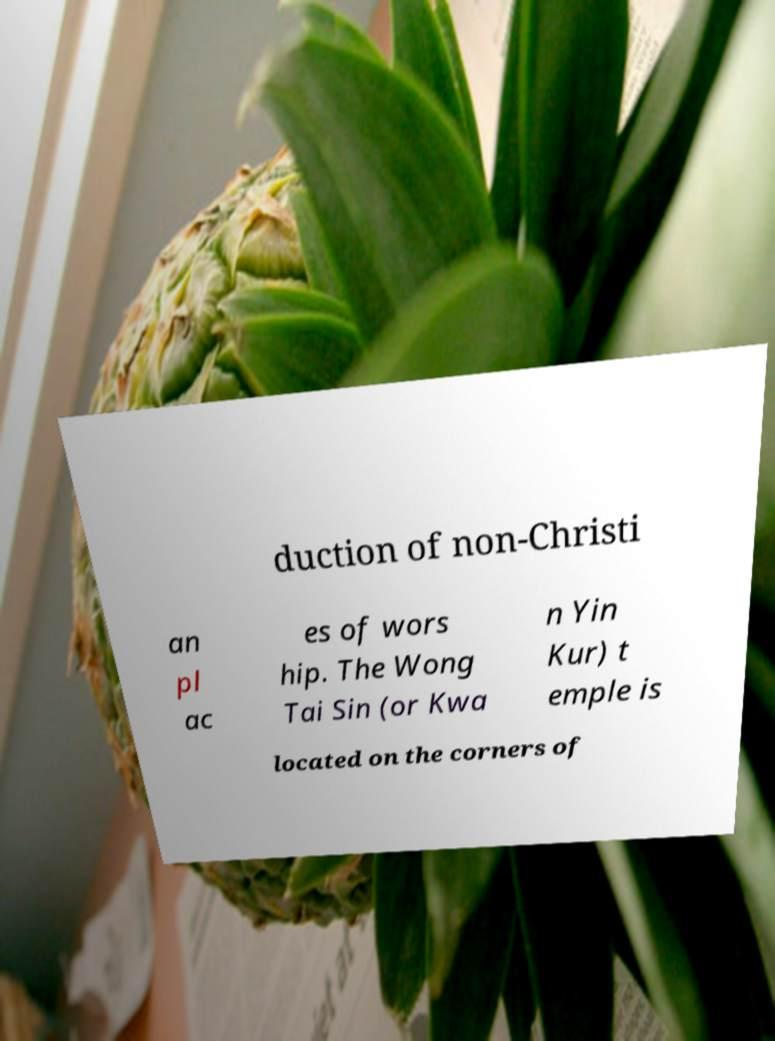What messages or text are displayed in this image? I need them in a readable, typed format. duction of non-Christi an pl ac es of wors hip. The Wong Tai Sin (or Kwa n Yin Kur) t emple is located on the corners of 